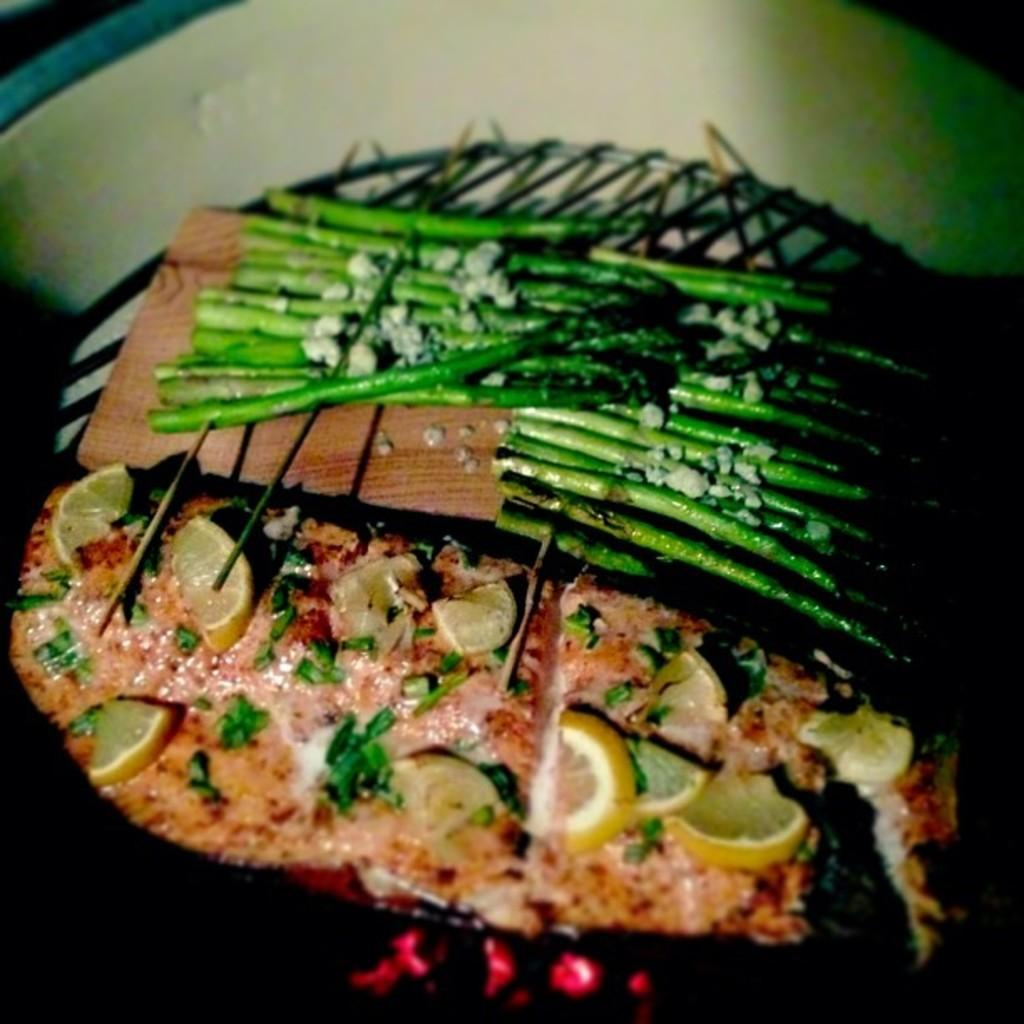What is on the board that is visible in the image? There is a board with food items in the image. Where is the board located? The board is on a grill. Who is present in the image besides the food items? There is a girl in the image. What is the girl standing on? The girl is on a white color surface. What books is the girl reading in the image? There are no books present in the image; the girl is standing near a board with food items on a grill. 